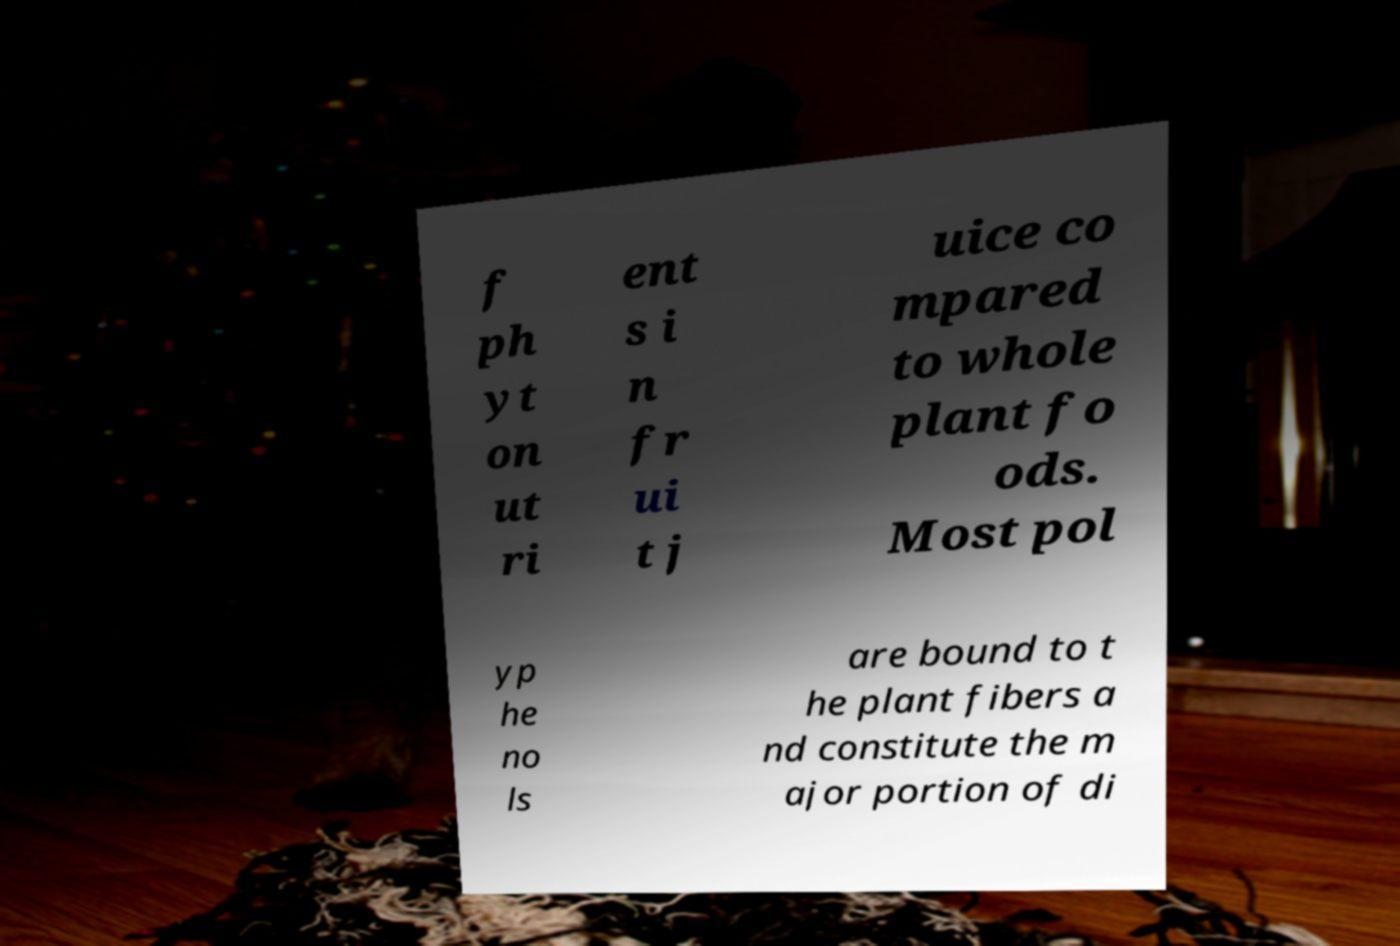Please identify and transcribe the text found in this image. f ph yt on ut ri ent s i n fr ui t j uice co mpared to whole plant fo ods. Most pol yp he no ls are bound to t he plant fibers a nd constitute the m ajor portion of di 